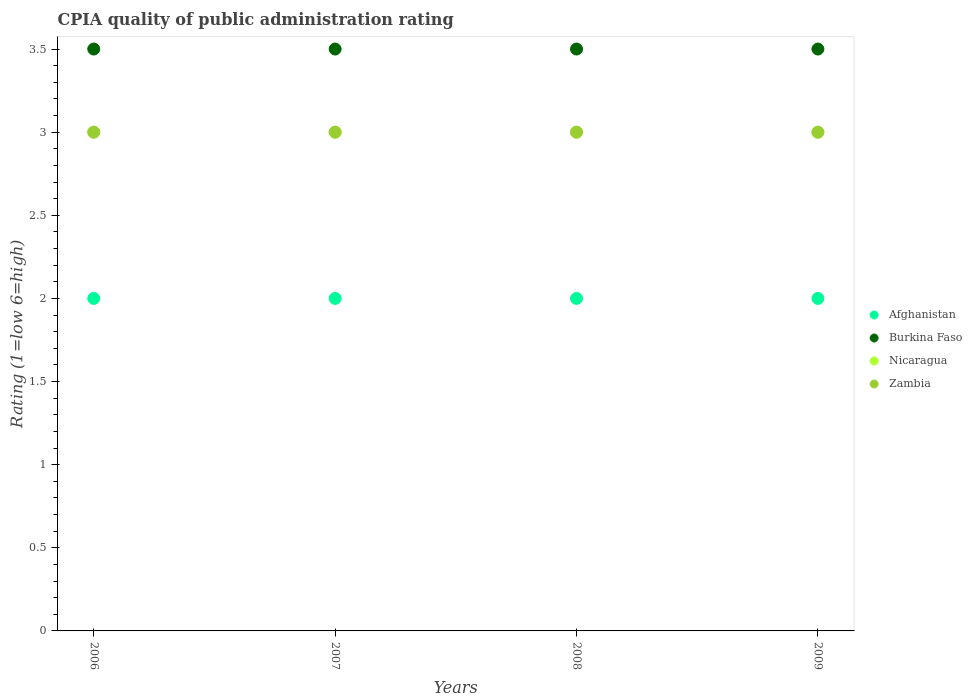Is the number of dotlines equal to the number of legend labels?
Ensure brevity in your answer.  Yes. What is the CPIA rating in Zambia in 2007?
Offer a very short reply. 3. What is the difference between the CPIA rating in Afghanistan in 2006 and that in 2007?
Keep it short and to the point. 0. What is the average CPIA rating in Afghanistan per year?
Give a very brief answer. 2. In the year 2006, what is the difference between the CPIA rating in Nicaragua and CPIA rating in Burkina Faso?
Your answer should be compact. -0.5. In how many years, is the CPIA rating in Afghanistan greater than 0.1?
Your answer should be very brief. 4. What is the difference between the highest and the lowest CPIA rating in Zambia?
Make the answer very short. 0. In how many years, is the CPIA rating in Burkina Faso greater than the average CPIA rating in Burkina Faso taken over all years?
Your response must be concise. 0. Is the CPIA rating in Afghanistan strictly greater than the CPIA rating in Nicaragua over the years?
Give a very brief answer. No. What is the difference between two consecutive major ticks on the Y-axis?
Offer a very short reply. 0.5. Are the values on the major ticks of Y-axis written in scientific E-notation?
Your response must be concise. No. Does the graph contain any zero values?
Provide a short and direct response. No. Does the graph contain grids?
Make the answer very short. No. Where does the legend appear in the graph?
Offer a very short reply. Center right. How many legend labels are there?
Provide a short and direct response. 4. What is the title of the graph?
Keep it short and to the point. CPIA quality of public administration rating. Does "Kyrgyz Republic" appear as one of the legend labels in the graph?
Your answer should be compact. No. What is the label or title of the Y-axis?
Your answer should be very brief. Rating (1=low 6=high). What is the Rating (1=low 6=high) in Burkina Faso in 2006?
Your answer should be very brief. 3.5. What is the Rating (1=low 6=high) in Zambia in 2006?
Offer a very short reply. 3. What is the Rating (1=low 6=high) of Zambia in 2007?
Make the answer very short. 3. What is the Rating (1=low 6=high) of Zambia in 2009?
Keep it short and to the point. 3. Across all years, what is the maximum Rating (1=low 6=high) of Burkina Faso?
Your answer should be very brief. 3.5. Across all years, what is the minimum Rating (1=low 6=high) in Afghanistan?
Provide a succinct answer. 2. Across all years, what is the minimum Rating (1=low 6=high) of Burkina Faso?
Ensure brevity in your answer.  3.5. What is the total Rating (1=low 6=high) of Burkina Faso in the graph?
Provide a succinct answer. 14. What is the difference between the Rating (1=low 6=high) in Burkina Faso in 2006 and that in 2007?
Offer a very short reply. 0. What is the difference between the Rating (1=low 6=high) of Nicaragua in 2006 and that in 2007?
Provide a succinct answer. 0. What is the difference between the Rating (1=low 6=high) in Afghanistan in 2006 and that in 2008?
Offer a terse response. 0. What is the difference between the Rating (1=low 6=high) of Nicaragua in 2006 and that in 2008?
Your answer should be very brief. 0. What is the difference between the Rating (1=low 6=high) in Zambia in 2006 and that in 2008?
Give a very brief answer. 0. What is the difference between the Rating (1=low 6=high) in Burkina Faso in 2006 and that in 2009?
Offer a very short reply. 0. What is the difference between the Rating (1=low 6=high) of Afghanistan in 2007 and that in 2008?
Your answer should be compact. 0. What is the difference between the Rating (1=low 6=high) of Nicaragua in 2007 and that in 2008?
Ensure brevity in your answer.  0. What is the difference between the Rating (1=low 6=high) of Zambia in 2007 and that in 2009?
Your answer should be very brief. 0. What is the difference between the Rating (1=low 6=high) of Nicaragua in 2008 and that in 2009?
Ensure brevity in your answer.  0. What is the difference between the Rating (1=low 6=high) of Afghanistan in 2006 and the Rating (1=low 6=high) of Burkina Faso in 2007?
Keep it short and to the point. -1.5. What is the difference between the Rating (1=low 6=high) of Afghanistan in 2006 and the Rating (1=low 6=high) of Nicaragua in 2007?
Keep it short and to the point. -1. What is the difference between the Rating (1=low 6=high) in Burkina Faso in 2006 and the Rating (1=low 6=high) in Nicaragua in 2007?
Your answer should be compact. 0.5. What is the difference between the Rating (1=low 6=high) of Nicaragua in 2006 and the Rating (1=low 6=high) of Zambia in 2007?
Give a very brief answer. 0. What is the difference between the Rating (1=low 6=high) in Afghanistan in 2006 and the Rating (1=low 6=high) in Nicaragua in 2008?
Make the answer very short. -1. What is the difference between the Rating (1=low 6=high) of Burkina Faso in 2006 and the Rating (1=low 6=high) of Zambia in 2008?
Offer a very short reply. 0.5. What is the difference between the Rating (1=low 6=high) of Afghanistan in 2006 and the Rating (1=low 6=high) of Burkina Faso in 2009?
Provide a succinct answer. -1.5. What is the difference between the Rating (1=low 6=high) of Afghanistan in 2006 and the Rating (1=low 6=high) of Nicaragua in 2009?
Provide a short and direct response. -1. What is the difference between the Rating (1=low 6=high) of Burkina Faso in 2006 and the Rating (1=low 6=high) of Zambia in 2009?
Provide a short and direct response. 0.5. What is the difference between the Rating (1=low 6=high) of Nicaragua in 2006 and the Rating (1=low 6=high) of Zambia in 2009?
Your answer should be compact. 0. What is the difference between the Rating (1=low 6=high) of Nicaragua in 2007 and the Rating (1=low 6=high) of Zambia in 2008?
Offer a terse response. 0. What is the difference between the Rating (1=low 6=high) in Afghanistan in 2007 and the Rating (1=low 6=high) in Nicaragua in 2009?
Make the answer very short. -1. What is the difference between the Rating (1=low 6=high) in Burkina Faso in 2007 and the Rating (1=low 6=high) in Nicaragua in 2009?
Your answer should be compact. 0.5. What is the difference between the Rating (1=low 6=high) in Nicaragua in 2007 and the Rating (1=low 6=high) in Zambia in 2009?
Offer a very short reply. 0. What is the difference between the Rating (1=low 6=high) in Afghanistan in 2008 and the Rating (1=low 6=high) in Nicaragua in 2009?
Provide a succinct answer. -1. What is the difference between the Rating (1=low 6=high) in Afghanistan in 2008 and the Rating (1=low 6=high) in Zambia in 2009?
Your answer should be compact. -1. What is the difference between the Rating (1=low 6=high) in Burkina Faso in 2008 and the Rating (1=low 6=high) in Zambia in 2009?
Offer a very short reply. 0.5. What is the difference between the Rating (1=low 6=high) in Nicaragua in 2008 and the Rating (1=low 6=high) in Zambia in 2009?
Make the answer very short. 0. In the year 2006, what is the difference between the Rating (1=low 6=high) in Afghanistan and Rating (1=low 6=high) in Zambia?
Keep it short and to the point. -1. In the year 2006, what is the difference between the Rating (1=low 6=high) of Burkina Faso and Rating (1=low 6=high) of Zambia?
Give a very brief answer. 0.5. In the year 2006, what is the difference between the Rating (1=low 6=high) in Nicaragua and Rating (1=low 6=high) in Zambia?
Provide a succinct answer. 0. In the year 2007, what is the difference between the Rating (1=low 6=high) of Afghanistan and Rating (1=low 6=high) of Zambia?
Give a very brief answer. -1. In the year 2007, what is the difference between the Rating (1=low 6=high) of Burkina Faso and Rating (1=low 6=high) of Zambia?
Offer a terse response. 0.5. In the year 2007, what is the difference between the Rating (1=low 6=high) of Nicaragua and Rating (1=low 6=high) of Zambia?
Your answer should be compact. 0. In the year 2008, what is the difference between the Rating (1=low 6=high) in Afghanistan and Rating (1=low 6=high) in Nicaragua?
Give a very brief answer. -1. In the year 2008, what is the difference between the Rating (1=low 6=high) of Burkina Faso and Rating (1=low 6=high) of Nicaragua?
Your response must be concise. 0.5. In the year 2008, what is the difference between the Rating (1=low 6=high) in Nicaragua and Rating (1=low 6=high) in Zambia?
Your response must be concise. 0. In the year 2009, what is the difference between the Rating (1=low 6=high) in Afghanistan and Rating (1=low 6=high) in Burkina Faso?
Your answer should be very brief. -1.5. In the year 2009, what is the difference between the Rating (1=low 6=high) of Afghanistan and Rating (1=low 6=high) of Nicaragua?
Provide a succinct answer. -1. In the year 2009, what is the difference between the Rating (1=low 6=high) of Burkina Faso and Rating (1=low 6=high) of Zambia?
Make the answer very short. 0.5. In the year 2009, what is the difference between the Rating (1=low 6=high) in Nicaragua and Rating (1=low 6=high) in Zambia?
Offer a very short reply. 0. What is the ratio of the Rating (1=low 6=high) in Burkina Faso in 2006 to that in 2007?
Offer a very short reply. 1. What is the ratio of the Rating (1=low 6=high) of Afghanistan in 2006 to that in 2008?
Your answer should be compact. 1. What is the ratio of the Rating (1=low 6=high) in Burkina Faso in 2006 to that in 2008?
Give a very brief answer. 1. What is the ratio of the Rating (1=low 6=high) in Zambia in 2006 to that in 2008?
Your answer should be compact. 1. What is the ratio of the Rating (1=low 6=high) in Afghanistan in 2006 to that in 2009?
Give a very brief answer. 1. What is the ratio of the Rating (1=low 6=high) in Nicaragua in 2006 to that in 2009?
Your answer should be very brief. 1. What is the ratio of the Rating (1=low 6=high) in Zambia in 2006 to that in 2009?
Provide a short and direct response. 1. What is the ratio of the Rating (1=low 6=high) of Burkina Faso in 2007 to that in 2009?
Offer a terse response. 1. What is the ratio of the Rating (1=low 6=high) in Afghanistan in 2008 to that in 2009?
Make the answer very short. 1. What is the difference between the highest and the second highest Rating (1=low 6=high) of Afghanistan?
Offer a terse response. 0. What is the difference between the highest and the second highest Rating (1=low 6=high) in Burkina Faso?
Ensure brevity in your answer.  0. What is the difference between the highest and the second highest Rating (1=low 6=high) of Nicaragua?
Give a very brief answer. 0. What is the difference between the highest and the lowest Rating (1=low 6=high) in Burkina Faso?
Offer a terse response. 0. 